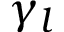Convert formula to latex. <formula><loc_0><loc_0><loc_500><loc_500>\gamma _ { l }</formula> 